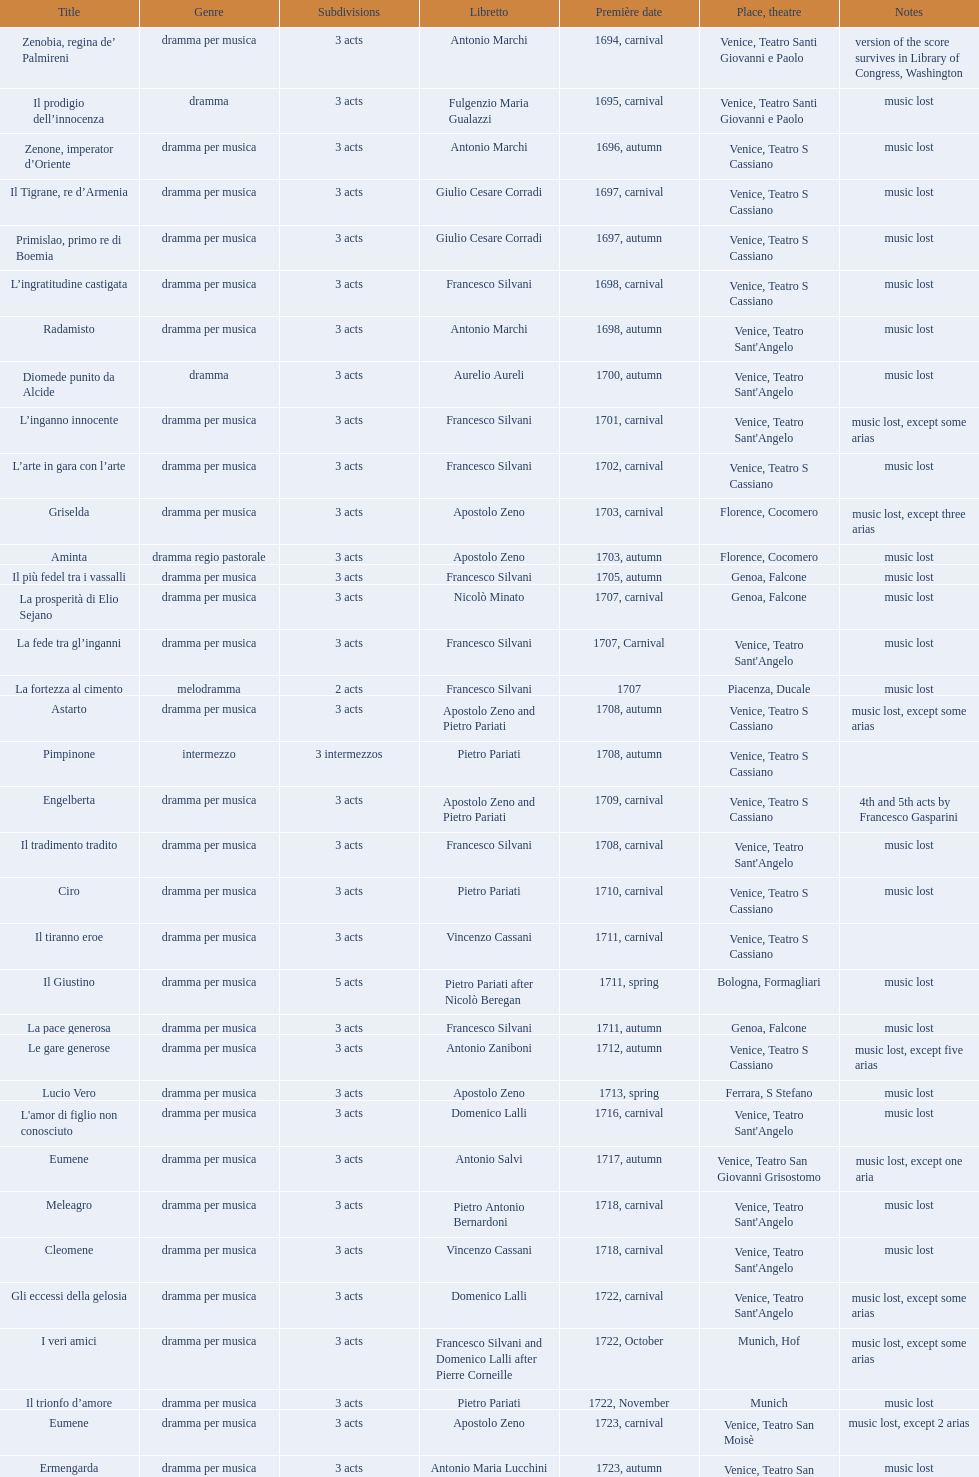Could you parse the entire table as a dict? {'header': ['Title', 'Genre', 'Sub\xaddivisions', 'Libretto', 'Première date', 'Place, theatre', 'Notes'], 'rows': [['Zenobia, regina de’ Palmireni', 'dramma per musica', '3 acts', 'Antonio Marchi', '1694, carnival', 'Venice, Teatro Santi Giovanni e Paolo', 'version of the score survives in Library of Congress, Washington'], ['Il prodigio dell’innocenza', 'dramma', '3 acts', 'Fulgenzio Maria Gualazzi', '1695, carnival', 'Venice, Teatro Santi Giovanni e Paolo', 'music lost'], ['Zenone, imperator d’Oriente', 'dramma per musica', '3 acts', 'Antonio Marchi', '1696, autumn', 'Venice, Teatro S Cassiano', 'music lost'], ['Il Tigrane, re d’Armenia', 'dramma per musica', '3 acts', 'Giulio Cesare Corradi', '1697, carnival', 'Venice, Teatro S Cassiano', 'music lost'], ['Primislao, primo re di Boemia', 'dramma per musica', '3 acts', 'Giulio Cesare Corradi', '1697, autumn', 'Venice, Teatro S Cassiano', 'music lost'], ['L’ingratitudine castigata', 'dramma per musica', '3 acts', 'Francesco Silvani', '1698, carnival', 'Venice, Teatro S Cassiano', 'music lost'], ['Radamisto', 'dramma per musica', '3 acts', 'Antonio Marchi', '1698, autumn', "Venice, Teatro Sant'Angelo", 'music lost'], ['Diomede punito da Alcide', 'dramma', '3 acts', 'Aurelio Aureli', '1700, autumn', "Venice, Teatro Sant'Angelo", 'music lost'], ['L’inganno innocente', 'dramma per musica', '3 acts', 'Francesco Silvani', '1701, carnival', "Venice, Teatro Sant'Angelo", 'music lost, except some arias'], ['L’arte in gara con l’arte', 'dramma per musica', '3 acts', 'Francesco Silvani', '1702, carnival', 'Venice, Teatro S Cassiano', 'music lost'], ['Griselda', 'dramma per musica', '3 acts', 'Apostolo Zeno', '1703, carnival', 'Florence, Cocomero', 'music lost, except three arias'], ['Aminta', 'dramma regio pastorale', '3 acts', 'Apostolo Zeno', '1703, autumn', 'Florence, Cocomero', 'music lost'], ['Il più fedel tra i vassalli', 'dramma per musica', '3 acts', 'Francesco Silvani', '1705, autumn', 'Genoa, Falcone', 'music lost'], ['La prosperità di Elio Sejano', 'dramma per musica', '3 acts', 'Nicolò Minato', '1707, carnival', 'Genoa, Falcone', 'music lost'], ['La fede tra gl’inganni', 'dramma per musica', '3 acts', 'Francesco Silvani', '1707, Carnival', "Venice, Teatro Sant'Angelo", 'music lost'], ['La fortezza al cimento', 'melodramma', '2 acts', 'Francesco Silvani', '1707', 'Piacenza, Ducale', 'music lost'], ['Astarto', 'dramma per musica', '3 acts', 'Apostolo Zeno and Pietro Pariati', '1708, autumn', 'Venice, Teatro S Cassiano', 'music lost, except some arias'], ['Pimpinone', 'intermezzo', '3 intermezzos', 'Pietro Pariati', '1708, autumn', 'Venice, Teatro S Cassiano', ''], ['Engelberta', 'dramma per musica', '3 acts', 'Apostolo Zeno and Pietro Pariati', '1709, carnival', 'Venice, Teatro S Cassiano', '4th and 5th acts by Francesco Gasparini'], ['Il tradimento tradito', 'dramma per musica', '3 acts', 'Francesco Silvani', '1708, carnival', "Venice, Teatro Sant'Angelo", 'music lost'], ['Ciro', 'dramma per musica', '3 acts', 'Pietro Pariati', '1710, carnival', 'Venice, Teatro S Cassiano', 'music lost'], ['Il tiranno eroe', 'dramma per musica', '3 acts', 'Vincenzo Cassani', '1711, carnival', 'Venice, Teatro S Cassiano', ''], ['Il Giustino', 'dramma per musica', '5 acts', 'Pietro Pariati after Nicolò Beregan', '1711, spring', 'Bologna, Formagliari', 'music lost'], ['La pace generosa', 'dramma per musica', '3 acts', 'Francesco Silvani', '1711, autumn', 'Genoa, Falcone', 'music lost'], ['Le gare generose', 'dramma per musica', '3 acts', 'Antonio Zaniboni', '1712, autumn', 'Venice, Teatro S Cassiano', 'music lost, except five arias'], ['Lucio Vero', 'dramma per musica', '3 acts', 'Apostolo Zeno', '1713, spring', 'Ferrara, S Stefano', 'music lost'], ["L'amor di figlio non conosciuto", 'dramma per musica', '3 acts', 'Domenico Lalli', '1716, carnival', "Venice, Teatro Sant'Angelo", 'music lost'], ['Eumene', 'dramma per musica', '3 acts', 'Antonio Salvi', '1717, autumn', 'Venice, Teatro San Giovanni Grisostomo', 'music lost, except one aria'], ['Meleagro', 'dramma per musica', '3 acts', 'Pietro Antonio Bernardoni', '1718, carnival', "Venice, Teatro Sant'Angelo", 'music lost'], ['Cleomene', 'dramma per musica', '3 acts', 'Vincenzo Cassani', '1718, carnival', "Venice, Teatro Sant'Angelo", 'music lost'], ['Gli eccessi della gelosia', 'dramma per musica', '3 acts', 'Domenico Lalli', '1722, carnival', "Venice, Teatro Sant'Angelo", 'music lost, except some arias'], ['I veri amici', 'dramma per musica', '3 acts', 'Francesco Silvani and Domenico Lalli after Pierre Corneille', '1722, October', 'Munich, Hof', 'music lost, except some arias'], ['Il trionfo d’amore', 'dramma per musica', '3 acts', 'Pietro Pariati', '1722, November', 'Munich', 'music lost'], ['Eumene', 'dramma per musica', '3 acts', 'Apostolo Zeno', '1723, carnival', 'Venice, Teatro San Moisè', 'music lost, except 2 arias'], ['Ermengarda', 'dramma per musica', '3 acts', 'Antonio Maria Lucchini', '1723, autumn', 'Venice, Teatro San Moisè', 'music lost'], ['Antigono, tutore di Filippo, re di Macedonia', 'tragedia', '5 acts', 'Giovanni Piazzon', '1724, carnival', 'Venice, Teatro San Moisè', '5th act by Giovanni Porta, music lost'], ['Scipione nelle Spagne', 'dramma per musica', '3 acts', 'Apostolo Zeno', '1724, Ascension', 'Venice, Teatro San Samuele', 'music lost'], ['Laodice', 'dramma per musica', '3 acts', 'Angelo Schietti', '1724, autumn', 'Venice, Teatro San Moisè', 'music lost, except 2 arias'], ['Didone abbandonata', 'tragedia', '3 acts', 'Metastasio', '1725, carnival', 'Venice, Teatro S Cassiano', 'music lost'], ["L'impresario delle Isole Canarie", 'intermezzo', '2 acts', 'Metastasio', '1725, carnival', 'Venice, Teatro S Cassiano', 'music lost'], ['Alcina delusa da Ruggero', 'dramma per musica', '3 acts', 'Antonio Marchi', '1725, autumn', 'Venice, Teatro S Cassiano', 'music lost'], ['I rivali generosi', 'dramma per musica', '3 acts', 'Apostolo Zeno', '1725', 'Brescia, Nuovo', ''], ['La Statira', 'dramma per musica', '3 acts', 'Apostolo Zeno and Pietro Pariati', '1726, Carnival', 'Rome, Teatro Capranica', ''], ['Malsazio e Fiammetta', 'intermezzo', '', '', '1726, Carnival', 'Rome, Teatro Capranica', ''], ['Il trionfo di Armida', 'dramma per musica', '3 acts', 'Girolamo Colatelli after Torquato Tasso', '1726, autumn', 'Venice, Teatro San Moisè', 'music lost'], ['L’incostanza schernita', 'dramma comico-pastorale', '3 acts', 'Vincenzo Cassani', '1727, Ascension', 'Venice, Teatro San Samuele', 'music lost, except some arias'], ['Le due rivali in amore', 'dramma per musica', '3 acts', 'Aurelio Aureli', '1728, autumn', 'Venice, Teatro San Moisè', 'music lost'], ['Il Satrapone', 'intermezzo', '', 'Salvi', '1729', 'Parma, Omodeo', ''], ['Li stratagemmi amorosi', 'dramma per musica', '3 acts', 'F Passerini', '1730, carnival', 'Venice, Teatro San Moisè', 'music lost'], ['Elenia', 'dramma per musica', '3 acts', 'Luisa Bergalli', '1730, carnival', "Venice, Teatro Sant'Angelo", 'music lost'], ['Merope', 'dramma', '3 acts', 'Apostolo Zeno', '1731, autumn', 'Prague, Sporck Theater', 'mostly by Albinoni, music lost'], ['Il più infedel tra gli amanti', 'dramma per musica', '3 acts', 'Angelo Schietti', '1731, autumn', 'Treviso, Dolphin', 'music lost'], ['Ardelinda', 'dramma', '3 acts', 'Bartolomeo Vitturi', '1732, autumn', "Venice, Teatro Sant'Angelo", 'music lost, except five arias'], ['Candalide', 'dramma per musica', '3 acts', 'Bartolomeo Vitturi', '1734, carnival', "Venice, Teatro Sant'Angelo", 'music lost'], ['Artamene', 'dramma per musica', '3 acts', 'Bartolomeo Vitturi', '1741, carnival', "Venice, Teatro Sant'Angelo", 'music lost']]} Which opera features the most acts, la fortezza al cimento or astarto? Astarto. 